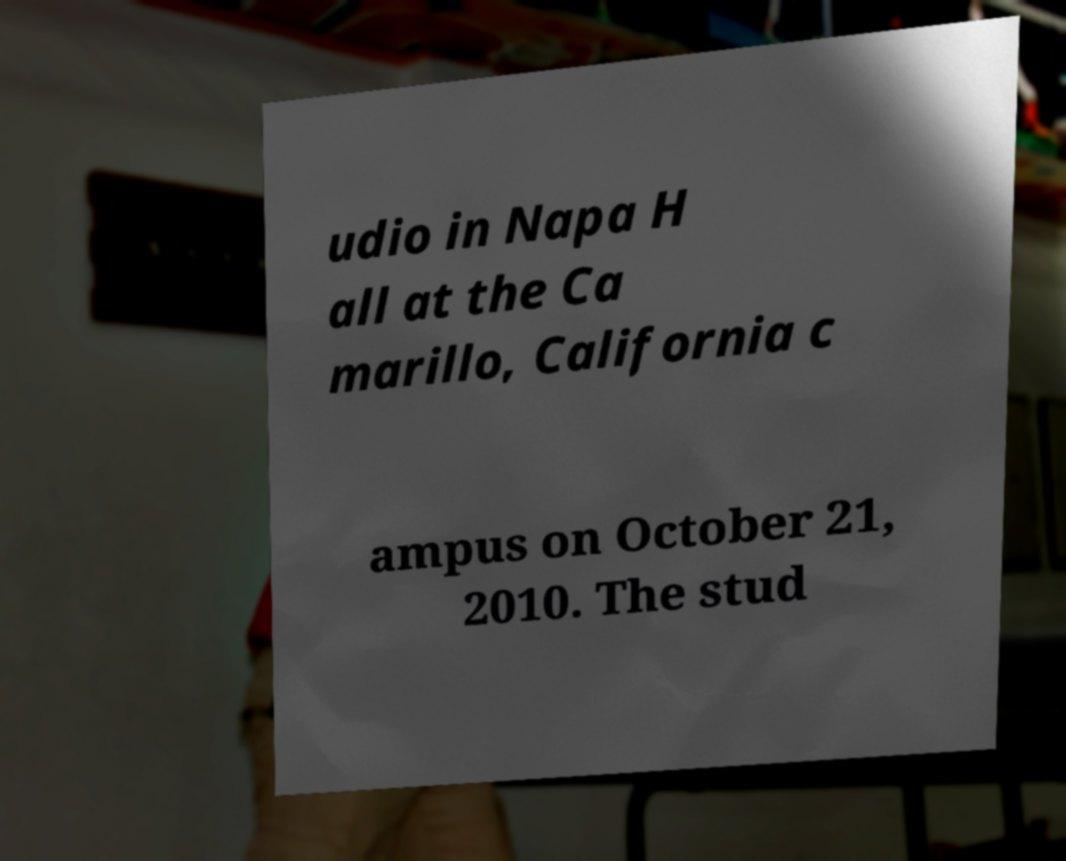Can you accurately transcribe the text from the provided image for me? udio in Napa H all at the Ca marillo, California c ampus on October 21, 2010. The stud 